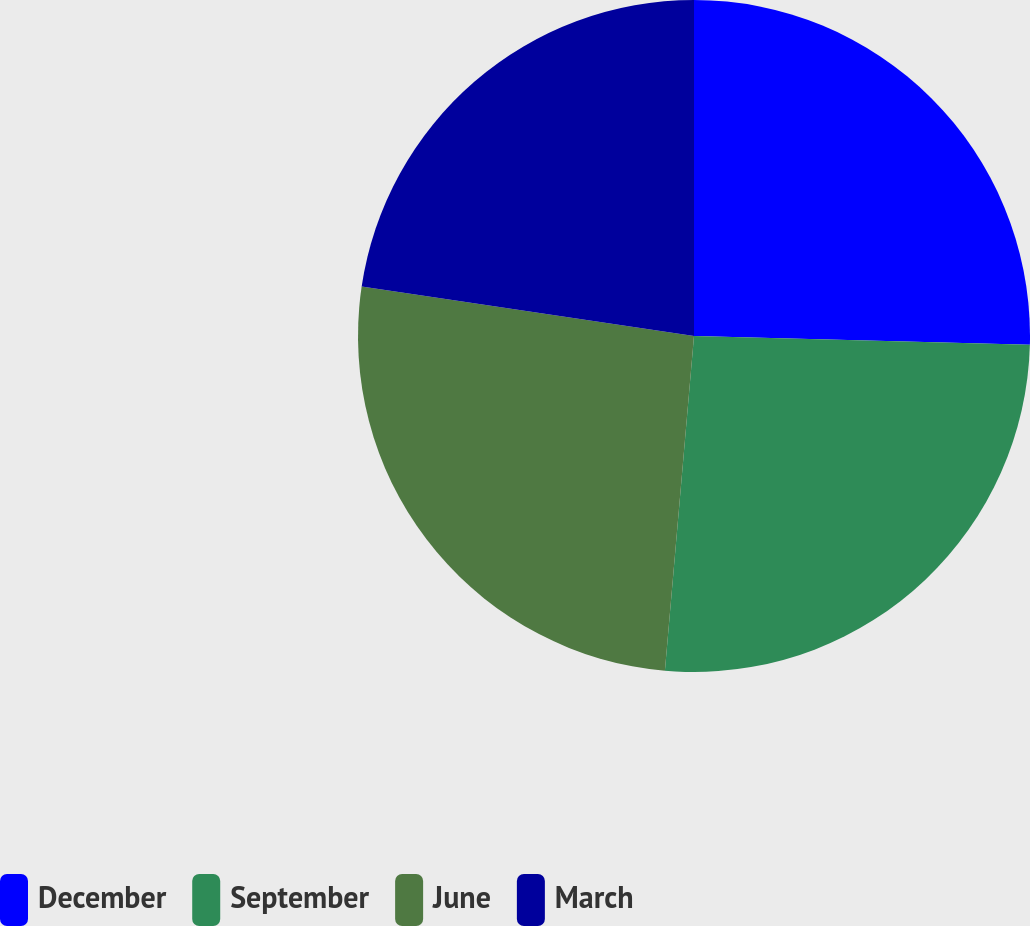Convert chart to OTSL. <chart><loc_0><loc_0><loc_500><loc_500><pie_chart><fcel>December<fcel>September<fcel>June<fcel>March<nl><fcel>25.41%<fcel>25.97%<fcel>25.97%<fcel>22.65%<nl></chart> 